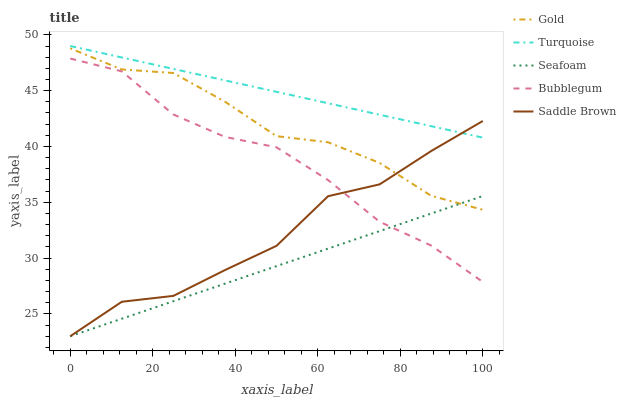Does Seafoam have the minimum area under the curve?
Answer yes or no. Yes. Does Turquoise have the maximum area under the curve?
Answer yes or no. Yes. Does Bubblegum have the minimum area under the curve?
Answer yes or no. No. Does Bubblegum have the maximum area under the curve?
Answer yes or no. No. Is Seafoam the smoothest?
Answer yes or no. Yes. Is Saddle Brown the roughest?
Answer yes or no. Yes. Is Bubblegum the smoothest?
Answer yes or no. No. Is Bubblegum the roughest?
Answer yes or no. No. Does Seafoam have the lowest value?
Answer yes or no. Yes. Does Bubblegum have the lowest value?
Answer yes or no. No. Does Turquoise have the highest value?
Answer yes or no. Yes. Does Bubblegum have the highest value?
Answer yes or no. No. Is Bubblegum less than Gold?
Answer yes or no. Yes. Is Turquoise greater than Gold?
Answer yes or no. Yes. Does Bubblegum intersect Seafoam?
Answer yes or no. Yes. Is Bubblegum less than Seafoam?
Answer yes or no. No. Is Bubblegum greater than Seafoam?
Answer yes or no. No. Does Bubblegum intersect Gold?
Answer yes or no. No. 